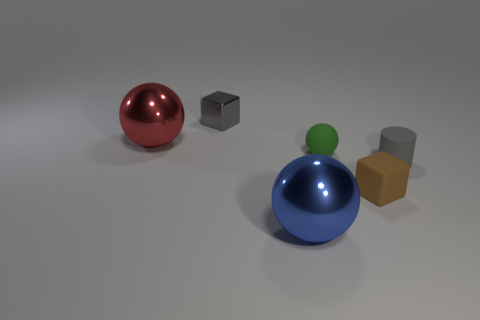Are there any other things that have the same color as the tiny rubber cube?
Provide a succinct answer. No. There is a red thing that is made of the same material as the blue ball; what is its shape?
Give a very brief answer. Sphere. There is a ball that is on the right side of the large red ball and behind the brown matte thing; what is it made of?
Keep it short and to the point. Rubber. Is there any other thing that is the same size as the gray block?
Ensure brevity in your answer.  Yes. Is the tiny matte sphere the same color as the tiny shiny thing?
Your answer should be very brief. No. There is a rubber object that is the same color as the tiny metal block; what is its shape?
Offer a very short reply. Cylinder. How many big blue metal things have the same shape as the gray shiny object?
Give a very brief answer. 0. There is a gray cube that is the same material as the large red object; what is its size?
Give a very brief answer. Small. Do the rubber cylinder and the brown matte block have the same size?
Give a very brief answer. Yes. Is there a big blue metal object?
Make the answer very short. Yes. 